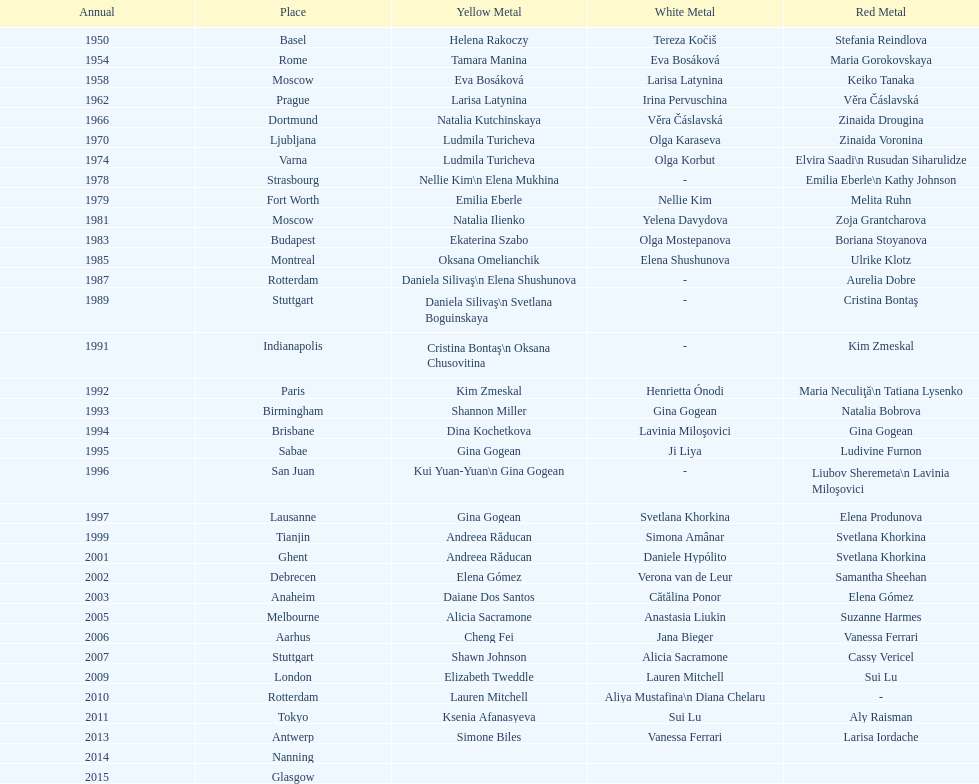How long is the time between the times the championship was held in moscow? 23 years. 